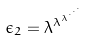<formula> <loc_0><loc_0><loc_500><loc_500>\epsilon _ { 2 } = \lambda ^ { \lambda ^ { \lambda ^ { \cdot ^ { \cdot ^ { \cdot } } } } }</formula> 